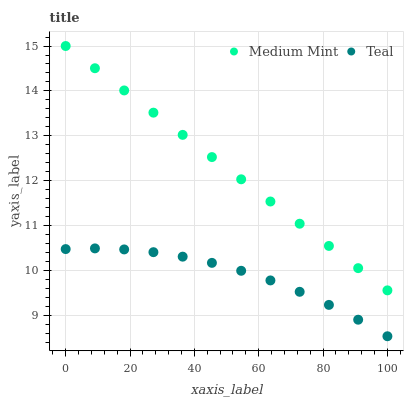Does Teal have the minimum area under the curve?
Answer yes or no. Yes. Does Medium Mint have the maximum area under the curve?
Answer yes or no. Yes. Does Teal have the maximum area under the curve?
Answer yes or no. No. Is Medium Mint the smoothest?
Answer yes or no. Yes. Is Teal the roughest?
Answer yes or no. Yes. Is Teal the smoothest?
Answer yes or no. No. Does Teal have the lowest value?
Answer yes or no. Yes. Does Medium Mint have the highest value?
Answer yes or no. Yes. Does Teal have the highest value?
Answer yes or no. No. Is Teal less than Medium Mint?
Answer yes or no. Yes. Is Medium Mint greater than Teal?
Answer yes or no. Yes. Does Teal intersect Medium Mint?
Answer yes or no. No. 